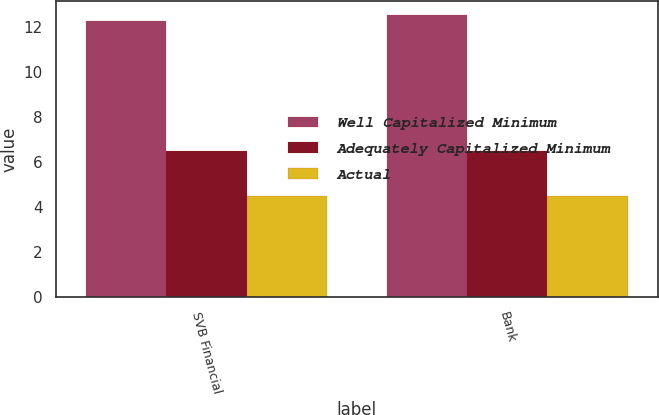<chart> <loc_0><loc_0><loc_500><loc_500><stacked_bar_chart><ecel><fcel>SVB Financial<fcel>Bank<nl><fcel>Well Capitalized Minimum<fcel>12.28<fcel>12.52<nl><fcel>Adequately Capitalized Minimum<fcel>6.5<fcel>6.5<nl><fcel>Actual<fcel>4.5<fcel>4.5<nl></chart> 